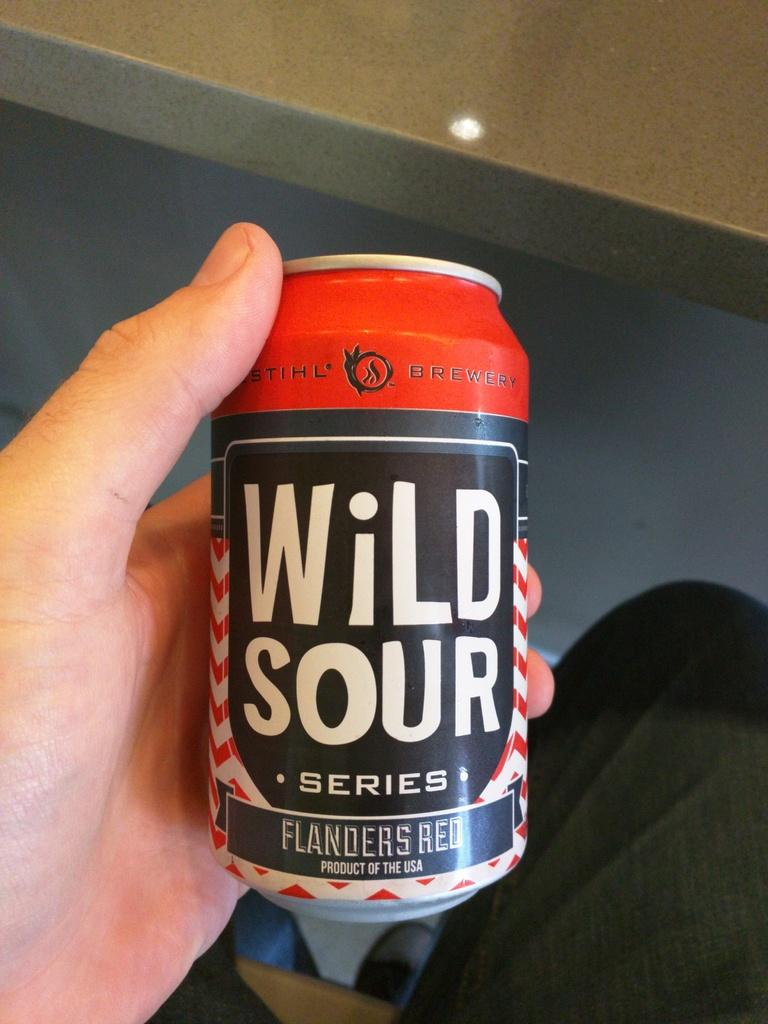<image>
Render a clear and concise summary of the photo. A can of Wild Sour series made by Flanders Red 